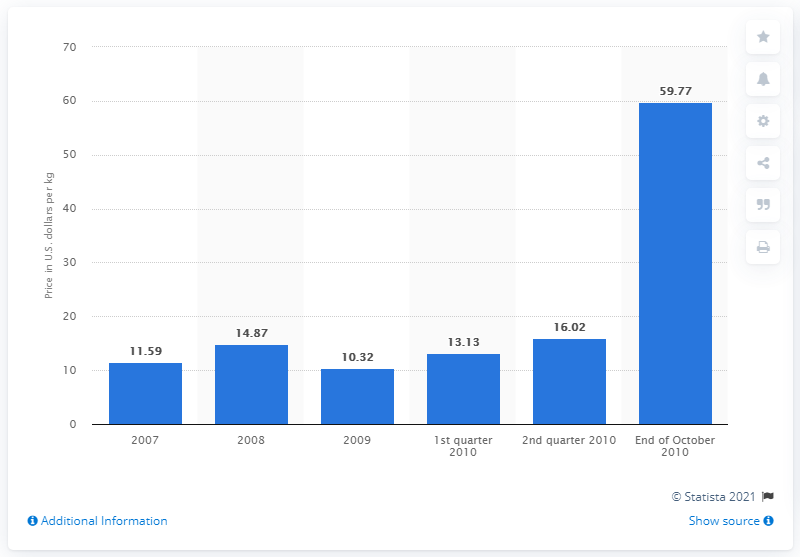Outline some significant characteristics in this image. At the end of October 2010, the price per kilogram of rare earths was 59.77 dollars and seventy-seven cents. 